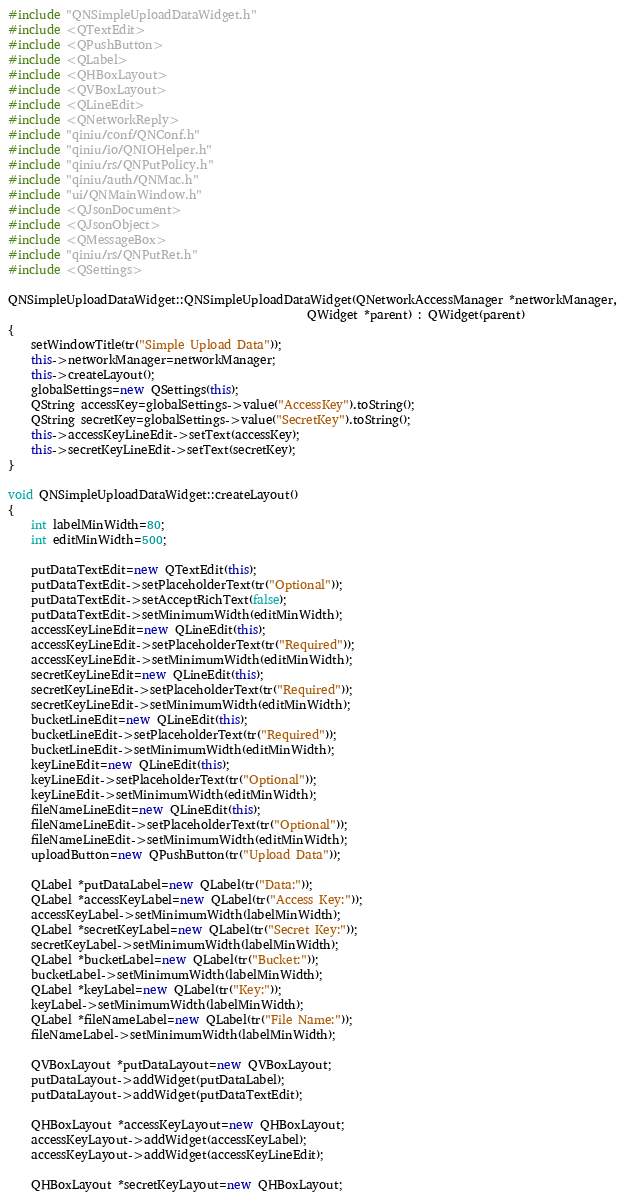Convert code to text. <code><loc_0><loc_0><loc_500><loc_500><_C++_>#include "QNSimpleUploadDataWidget.h"
#include <QTextEdit>
#include <QPushButton>
#include <QLabel>
#include <QHBoxLayout>
#include <QVBoxLayout>
#include <QLineEdit>
#include <QNetworkReply>
#include "qiniu/conf/QNConf.h"
#include "qiniu/io/QNIOHelper.h"
#include "qiniu/rs/QNPutPolicy.h"
#include "qiniu/auth/QNMac.h"
#include "ui/QNMainWindow.h"
#include <QJsonDocument>
#include <QJsonObject>
#include <QMessageBox>
#include "qiniu/rs/QNPutRet.h"
#include <QSettings>

QNSimpleUploadDataWidget::QNSimpleUploadDataWidget(QNetworkAccessManager *networkManager,
                                                   QWidget *parent) : QWidget(parent)
{
    setWindowTitle(tr("Simple Upload Data"));
    this->networkManager=networkManager;
    this->createLayout();
    globalSettings=new QSettings(this);
    QString accessKey=globalSettings->value("AccessKey").toString();
    QString secretKey=globalSettings->value("SecretKey").toString();
    this->accessKeyLineEdit->setText(accessKey);
    this->secretKeyLineEdit->setText(secretKey);
}

void QNSimpleUploadDataWidget::createLayout()
{
    int labelMinWidth=80;
    int editMinWidth=500;

    putDataTextEdit=new QTextEdit(this);
    putDataTextEdit->setPlaceholderText(tr("Optional"));
    putDataTextEdit->setAcceptRichText(false);
    putDataTextEdit->setMinimumWidth(editMinWidth);
    accessKeyLineEdit=new QLineEdit(this);
    accessKeyLineEdit->setPlaceholderText(tr("Required"));
    accessKeyLineEdit->setMinimumWidth(editMinWidth);
    secretKeyLineEdit=new QLineEdit(this);
    secretKeyLineEdit->setPlaceholderText(tr("Required"));
    secretKeyLineEdit->setMinimumWidth(editMinWidth);
    bucketLineEdit=new QLineEdit(this);
    bucketLineEdit->setPlaceholderText(tr("Required"));
    bucketLineEdit->setMinimumWidth(editMinWidth);
    keyLineEdit=new QLineEdit(this);
    keyLineEdit->setPlaceholderText(tr("Optional"));
    keyLineEdit->setMinimumWidth(editMinWidth);
    fileNameLineEdit=new QLineEdit(this);
    fileNameLineEdit->setPlaceholderText(tr("Optional"));
    fileNameLineEdit->setMinimumWidth(editMinWidth);
    uploadButton=new QPushButton(tr("Upload Data"));

    QLabel *putDataLabel=new QLabel(tr("Data:"));
    QLabel *accessKeyLabel=new QLabel(tr("Access Key:"));
    accessKeyLabel->setMinimumWidth(labelMinWidth);
    QLabel *secretKeyLabel=new QLabel(tr("Secret Key:"));
    secretKeyLabel->setMinimumWidth(labelMinWidth);
    QLabel *bucketLabel=new QLabel(tr("Bucket:"));
    bucketLabel->setMinimumWidth(labelMinWidth);
    QLabel *keyLabel=new QLabel(tr("Key:"));
    keyLabel->setMinimumWidth(labelMinWidth);
    QLabel *fileNameLabel=new QLabel(tr("File Name:"));
    fileNameLabel->setMinimumWidth(labelMinWidth);

    QVBoxLayout *putDataLayout=new QVBoxLayout;
    putDataLayout->addWidget(putDataLabel);
    putDataLayout->addWidget(putDataTextEdit);

    QHBoxLayout *accessKeyLayout=new QHBoxLayout;
    accessKeyLayout->addWidget(accessKeyLabel);
    accessKeyLayout->addWidget(accessKeyLineEdit);

    QHBoxLayout *secretKeyLayout=new QHBoxLayout;</code> 